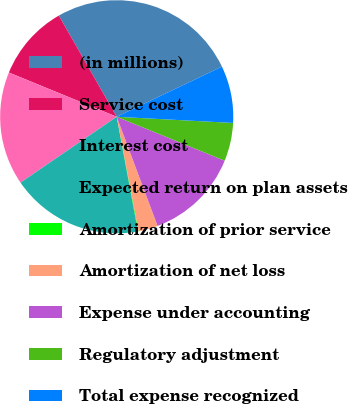<chart> <loc_0><loc_0><loc_500><loc_500><pie_chart><fcel>(in millions)<fcel>Service cost<fcel>Interest cost<fcel>Expected return on plan assets<fcel>Amortization of prior service<fcel>Amortization of net loss<fcel>Expense under accounting<fcel>Regulatory adjustment<fcel>Total expense recognized<nl><fcel>26.19%<fcel>10.53%<fcel>15.75%<fcel>18.36%<fcel>0.09%<fcel>2.7%<fcel>13.14%<fcel>5.31%<fcel>7.92%<nl></chart> 